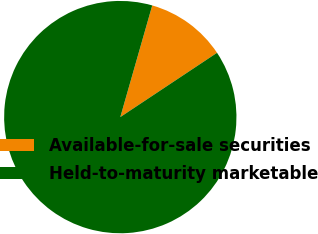<chart> <loc_0><loc_0><loc_500><loc_500><pie_chart><fcel>Available-for-sale securities<fcel>Held-to-maturity marketable<nl><fcel>11.23%<fcel>88.77%<nl></chart> 